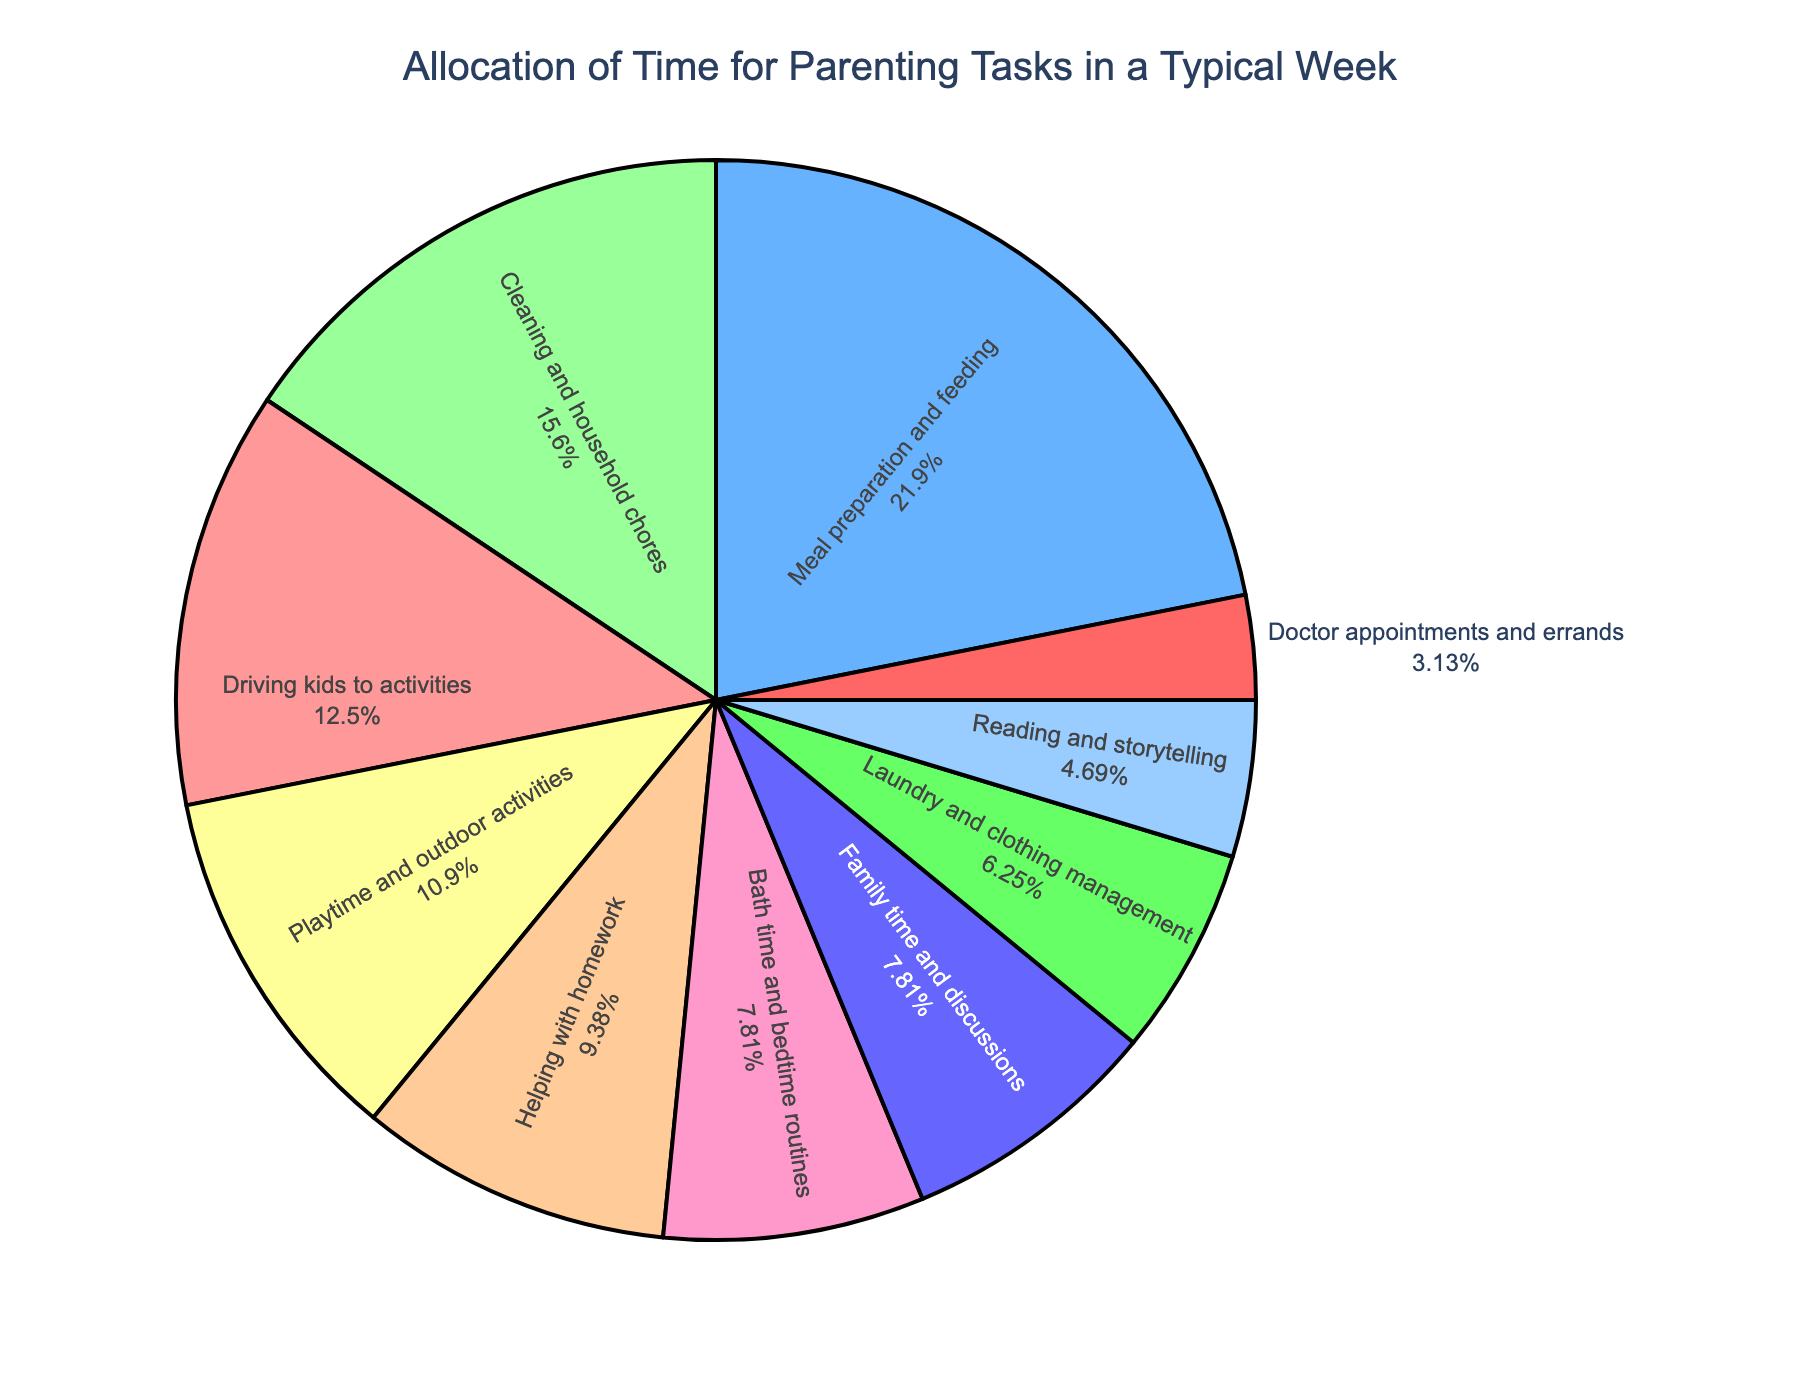What task takes up the largest percentage of the week? The portion of the pie chart with the largest area represents meal preparation and feeding. This is indicated by its larger size compared to other segments and the associated percentage value.
Answer: Meal preparation and feeding What's the total time spent on cleaning and household chores and laundry and clothing management combined? From the chart, cleaning and household chores take 10 hours, and laundry and clothing management take 4 hours. Adding these together gives 10 + 4 = 14 hours.
Answer: 14 hours Which tasks combined take more time: driving kids to activities and playtime & outdoor activities or meal preparation and feeding? Driving kids to activities is 8 hours and playtime & outdoor activities is 7 hours, which sums up to 8 + 7 = 15 hours. Meal preparation and feeding are 14 hours. Since 15 hours is greater than 14 hours, driving kids to activities and playtime & outdoor activities take more time.
Answer: Driving kids to activities and playtime & outdoor activities Which task takes up less time: bath time and bedtime routines or reading and storytelling? By comparing the sizes of the segments and the associated hours, reading and storytelling take 3 hours, and bath time and bedtime routines take 5 hours. Since 3 hours is less than 5 hours, reading and storytelling take less time.
Answer: Reading and storytelling What's the percentage of time spent on doctor appointments and errands? The pie chart segment for doctor appointments and errands shows the associated percentage value directly.
Answer: 3% What is the combined percentage of family time and discussions and helping with homework? The family time and discussions segment and helping with homework segment each have a percentage displayed. Adding the percentage values together will give the combined percentage.
Answer: 15% Which task has the smallest area in the pie chart? The smallest area in the pie chart is easily identifiable by its tiny size compared to other segments, which corresponds to doctor appointments and errands.
Answer: Doctor appointments and errands How much more time is spent on meal preparation and feeding than helping with homework? Meal preparation and feeding take 14 hours, while helping with homework takes 6 hours. Subtracting these gives 14 - 6 = 8 hours.
Answer: 8 hours 